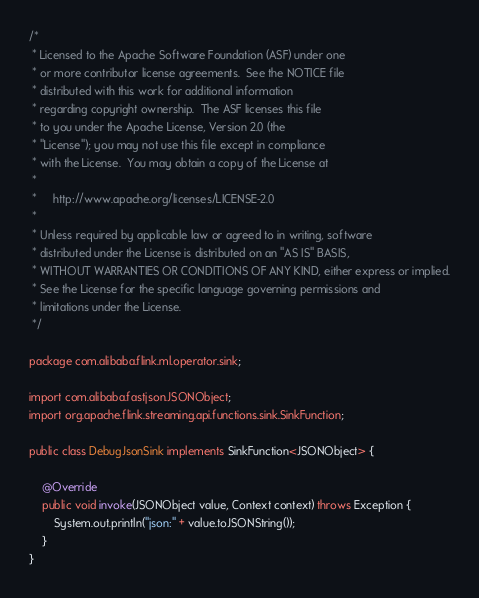Convert code to text. <code><loc_0><loc_0><loc_500><loc_500><_Java_>/*
 * Licensed to the Apache Software Foundation (ASF) under one
 * or more contributor license agreements.  See the NOTICE file
 * distributed with this work for additional information
 * regarding copyright ownership.  The ASF licenses this file
 * to you under the Apache License, Version 2.0 (the
 * "License"); you may not use this file except in compliance
 * with the License.  You may obtain a copy of the License at
 *
 *     http://www.apache.org/licenses/LICENSE-2.0
 *
 * Unless required by applicable law or agreed to in writing, software
 * distributed under the License is distributed on an "AS IS" BASIS,
 * WITHOUT WARRANTIES OR CONDITIONS OF ANY KIND, either express or implied.
 * See the License for the specific language governing permissions and
 * limitations under the License.
 */

package com.alibaba.flink.ml.operator.sink;

import com.alibaba.fastjson.JSONObject;
import org.apache.flink.streaming.api.functions.sink.SinkFunction;

public class DebugJsonSink implements SinkFunction<JSONObject> {

    @Override
    public void invoke(JSONObject value, Context context) throws Exception {
        System.out.println("json:" + value.toJSONString());
    }
}
</code> 